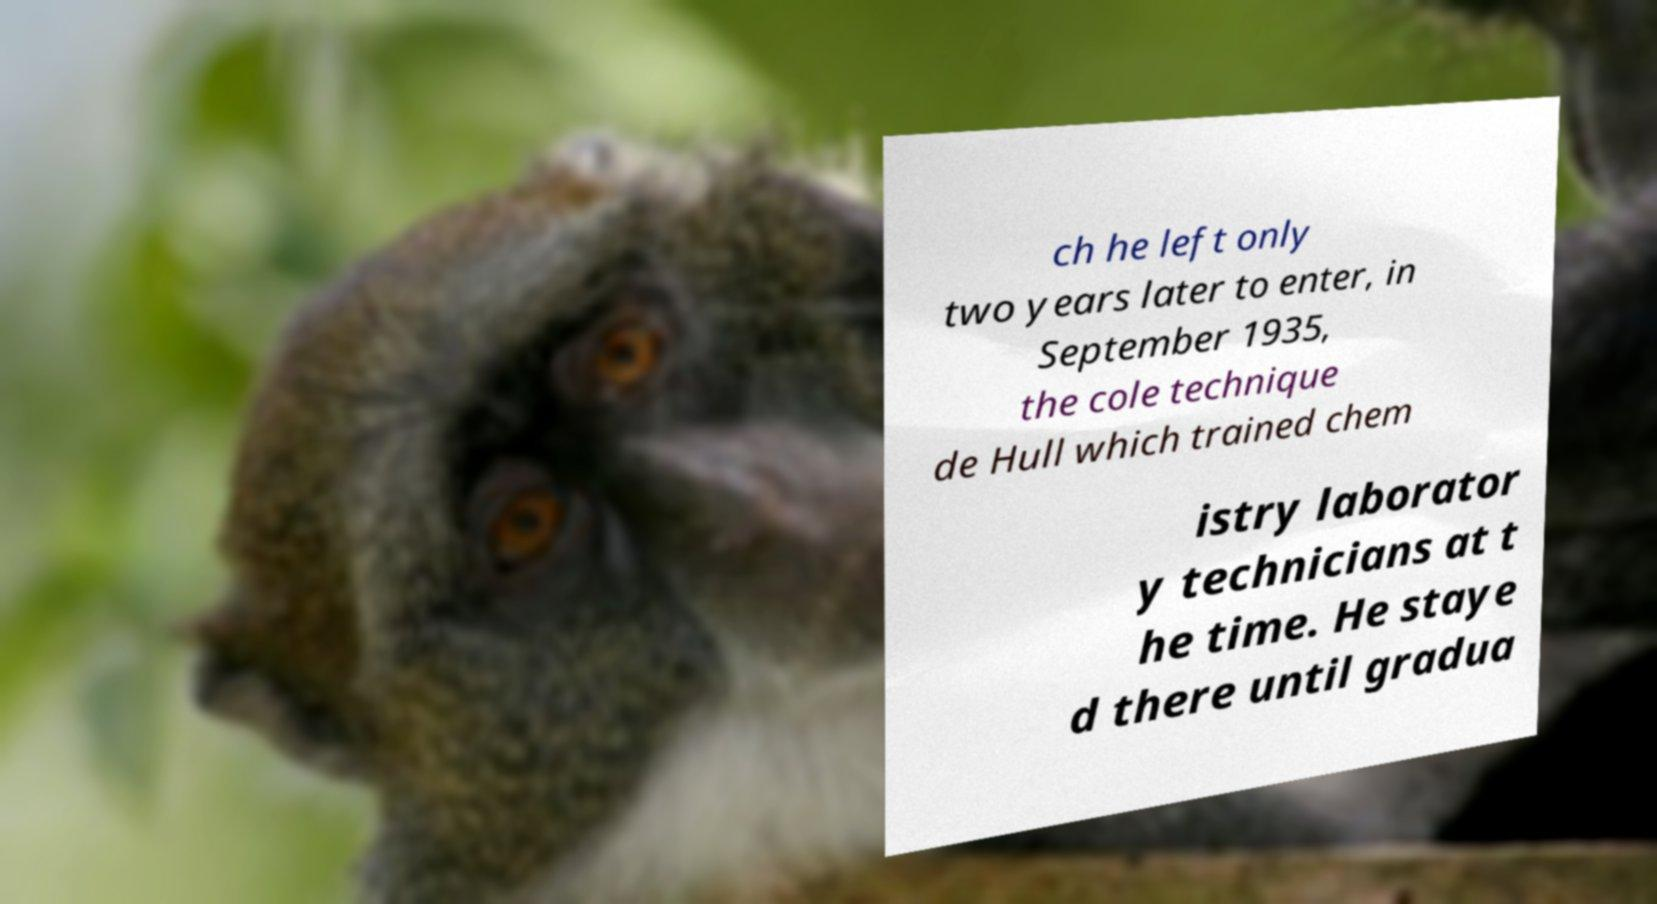There's text embedded in this image that I need extracted. Can you transcribe it verbatim? ch he left only two years later to enter, in September 1935, the cole technique de Hull which trained chem istry laborator y technicians at t he time. He staye d there until gradua 